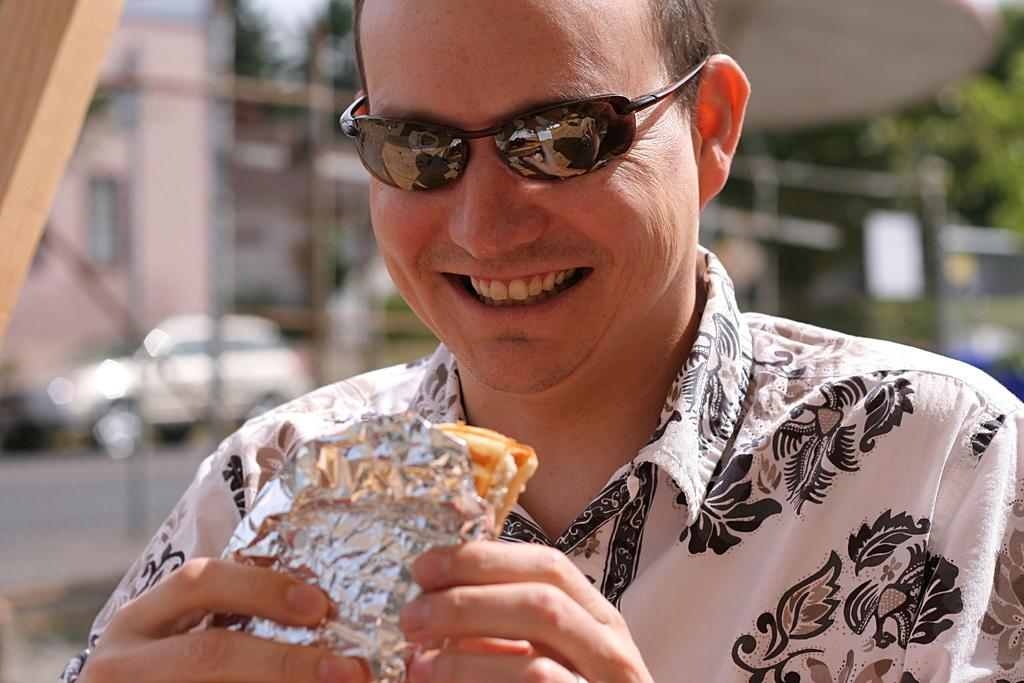What is the main subject of the image? There is a person standing in the image. What is the person holding in the image? The person is holding a food item. Can you describe the background of the image? The background of the image is blurred. What type of plant is growing on the person's wrist in the image? There is no plant growing on the person's wrist in the image. What is the person painting on the canvas in the image? There is no canvas present in the image. 